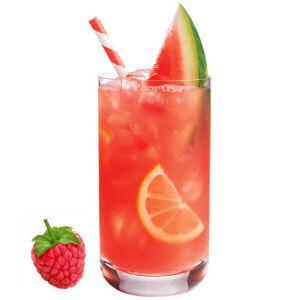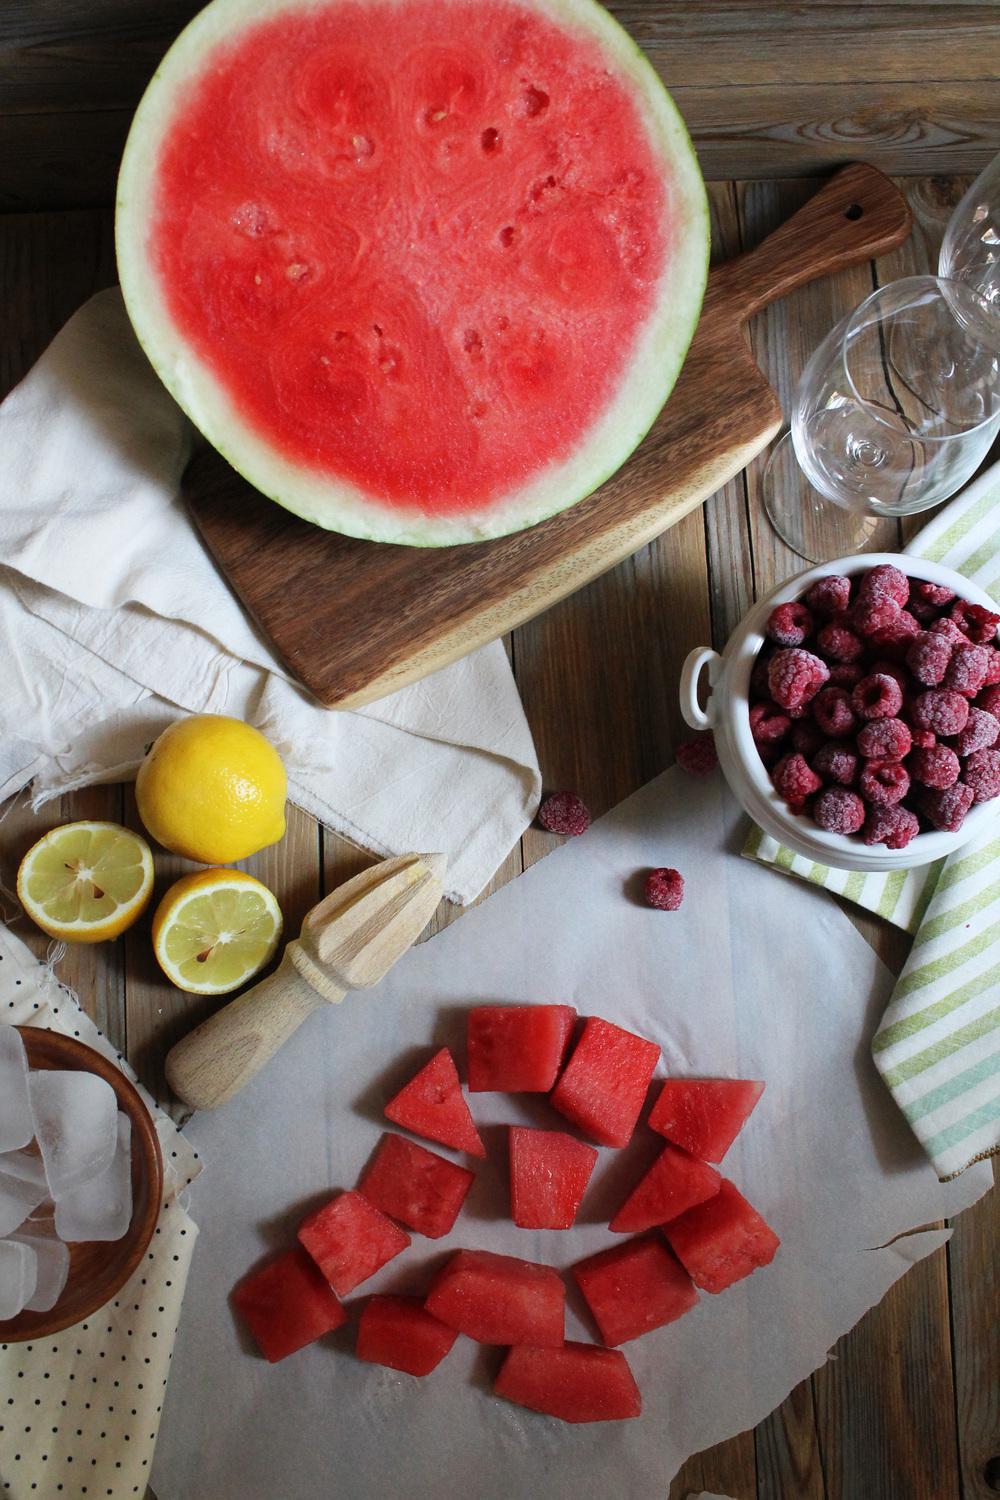The first image is the image on the left, the second image is the image on the right. Assess this claim about the two images: "There is exactly one straw in a drink.". Correct or not? Answer yes or no. Yes. The first image is the image on the left, the second image is the image on the right. Examine the images to the left and right. Is the description "In one image, one or more fruit drinks is garnished with raspberries, lemon and mint, and has a straw extended from the top, while a second image shows cut watermelon." accurate? Answer yes or no. No. 